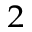Convert formula to latex. <formula><loc_0><loc_0><loc_500><loc_500>^ { 2 }</formula> 